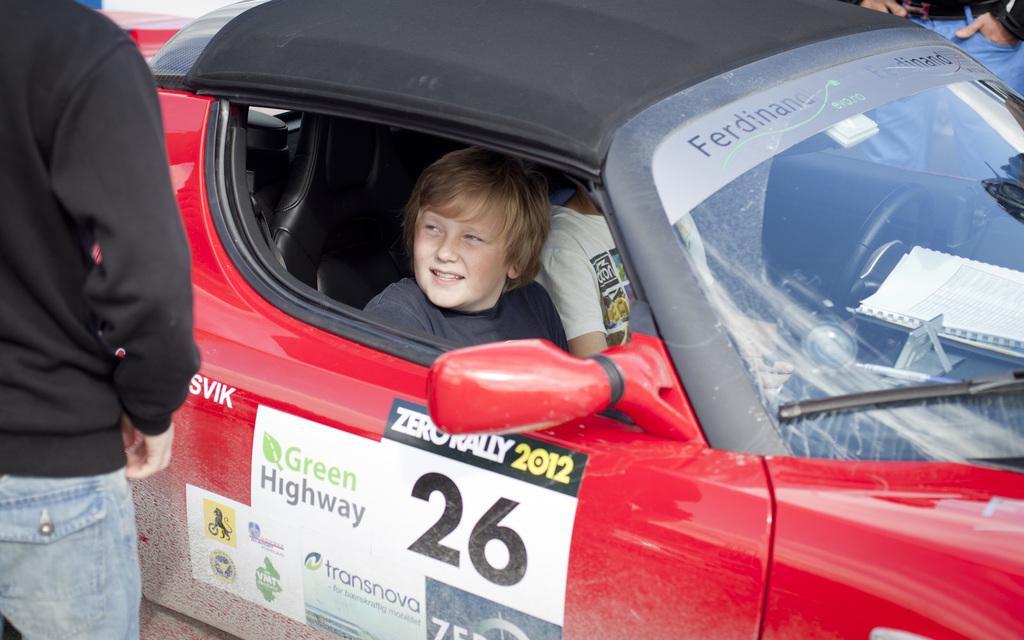Could you give a brief overview of what you see in this image? In the image we can see there are people who are sitting the car and there is another person standing here. 